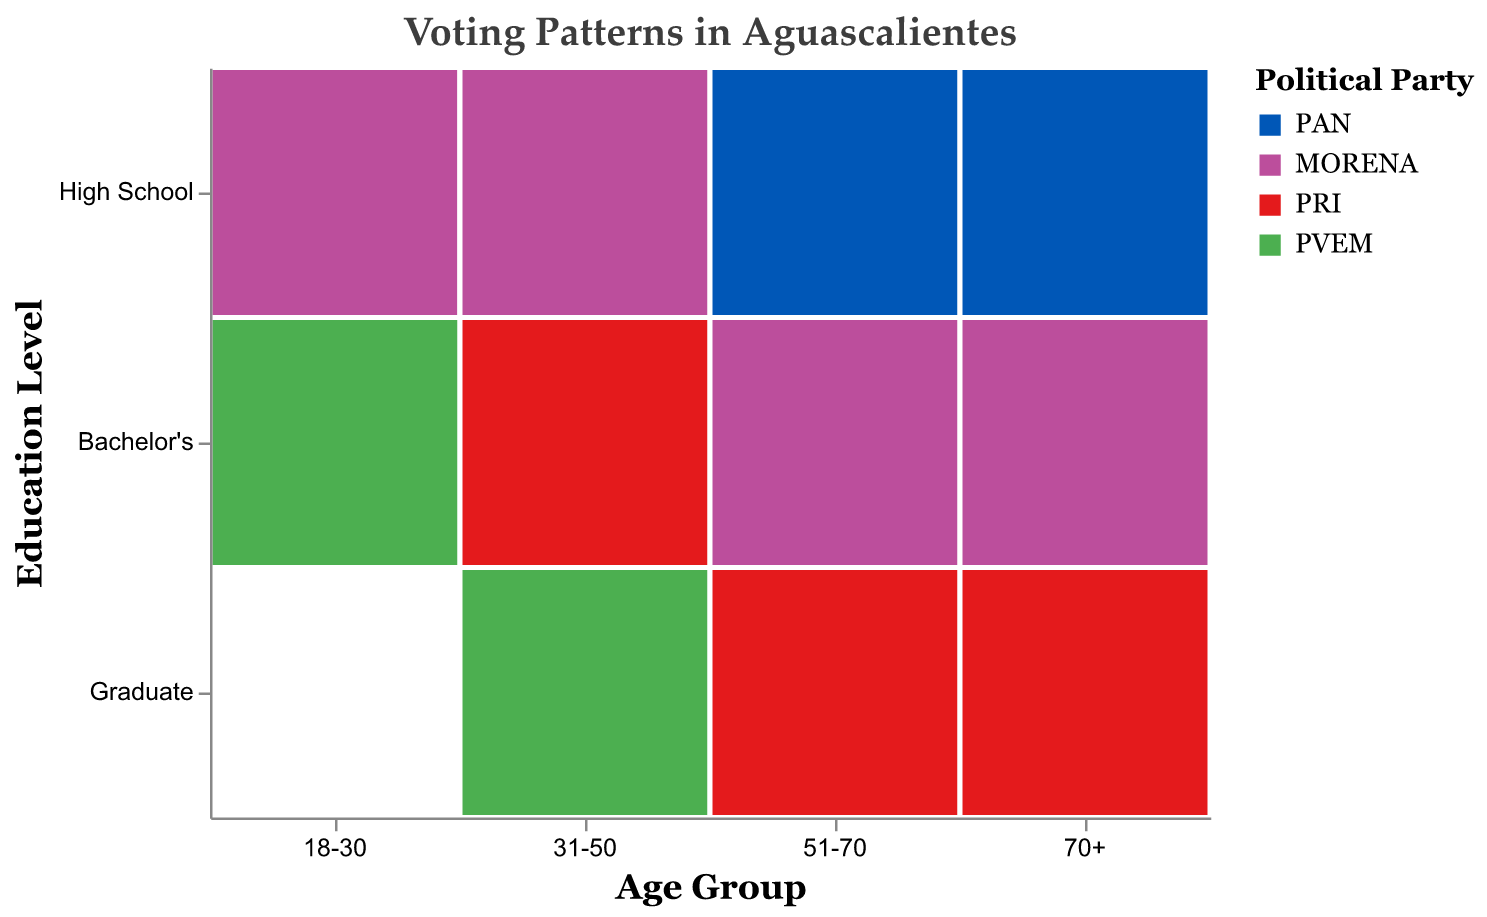How many political parties are represented in the voting patterns? The mosaic plot uses different colors to represent each political party. By looking at the legend, we can count the number of unique political parties listed.
Answer: 4 Which education level is associated with the most diverse age groups? To determine this, count the number of age groups associated with each education level in the plot. "High School" is associated with all age groups (18-30, 31-50, 51-70, 70+).
Answer: High School Which age groups are associated with the PAN party? Check the colors representing the PAN party across the age groups. PAN is associated with the age groups 18-30, 31-50, 51-70, and 70+.
Answer: 18-30, 31-50, 51-70, 70+ Are there any political parties that are associated with all education levels? Examine the color markers for each party in the education levels. PRI is represented in "Bachelor's" and "Graduate", and PVEM is not represented in "High School", so only PAN and MORENA are represented in all education levels.
Answer: PAN, MORENA In which age group does the Graduate education level have the least political diversity? Check the Graduate education level in each age group. For the age group 31-50, there's only the PVEM party listed.
Answer: 31-50 Which age group has the highest representation of MORENA? Examine the age groups for the MORENA color. MORENA is represented in every age group except 31-50 but appears twice in 51-70 and 70+.
Answer: 51-70, 70+ Do any age groups have exclusive political party representation? Look for age groups where only one party is represented. This does not occur as every age group has representation from multiple parties.
Answer: No Does the Bachelor's education level have more parties represented compared to the High School level? Count the number of unique parties for both education levels. Bachelor's has PAN, MORENA, PRI, which are 3 parties, while High School has PAN and MORENA, so 2.
Answer: Yes Are there any discrepancies between educational levels favoring a specific party in the younger age groups (18-30)? Check the 18-30 age group. High School supports PAN and MORENA, while Bachelor's supports PRI and PVEM. No single party dominates both educational levels.
Answer: No Which age-education combination is exclusively supporting one political party? Scan the plot for cells with only one color. The age group 31-50 with Graduate education level supports exclusively PVEM.
Answer: 31-50, Graduate 